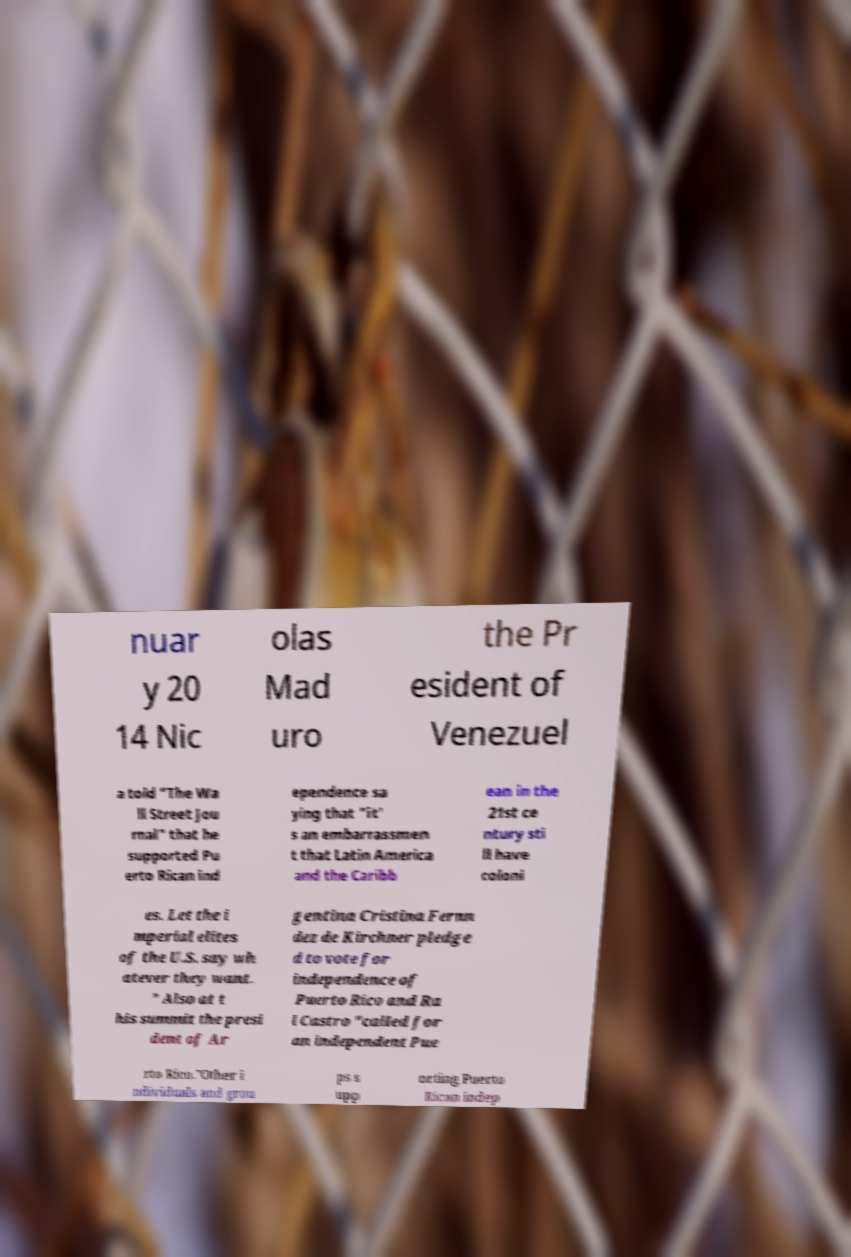There's text embedded in this image that I need extracted. Can you transcribe it verbatim? nuar y 20 14 Nic olas Mad uro the Pr esident of Venezuel a told "The Wa ll Street Jou rnal" that he supported Pu erto Rican ind ependence sa ying that "it' s an embarrassmen t that Latin America and the Caribb ean in the 21st ce ntury sti ll have coloni es. Let the i mperial elites of the U.S. say wh atever they want. " Also at t his summit the presi dent of Ar gentina Cristina Fernn dez de Kirchner pledge d to vote for independence of Puerto Rico and Ra l Castro "called for an independent Pue rto Rico."Other i ndividuals and grou ps s upp orting Puerto Rican indep 